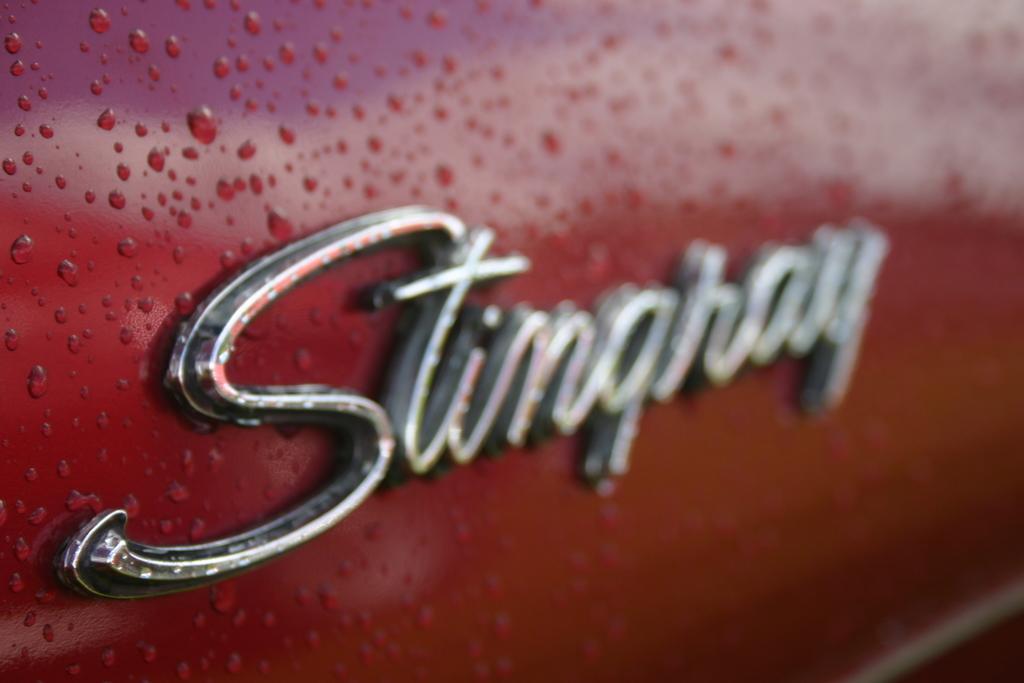Could you give a brief overview of what you see in this image? In this picture there is a name in the center of the image, on a car, which is red in color. 